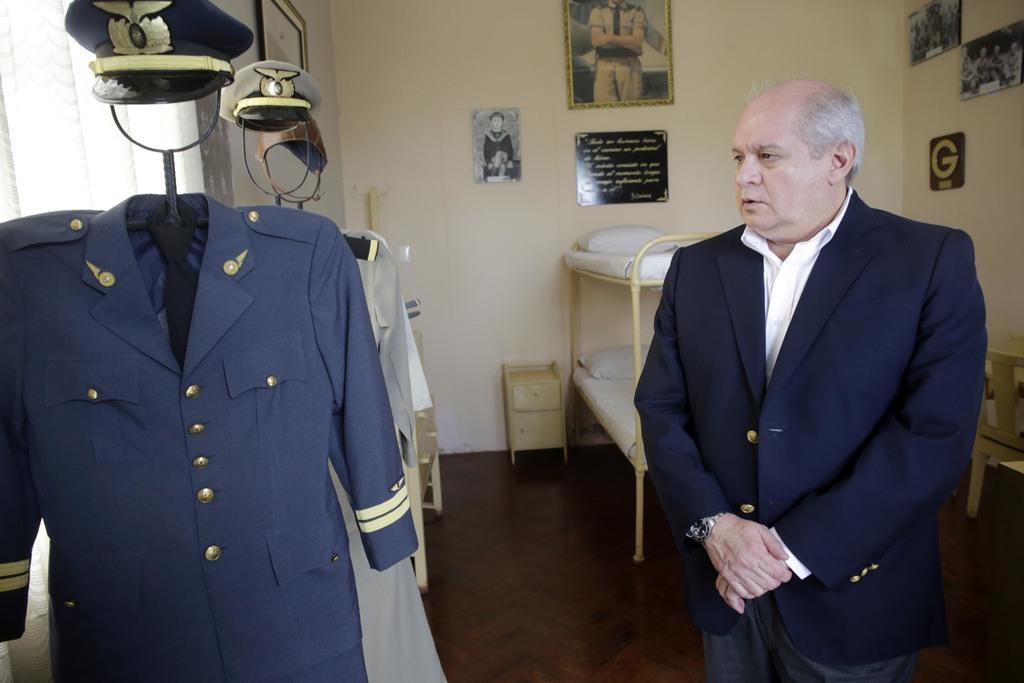In one or two sentences, can you explain what this image depicts? In the picture there is a person standing, beside the person there are hangers with the dresses and caps, behind the person there is a bed, there is a wall, on the wall there are many frames present. 